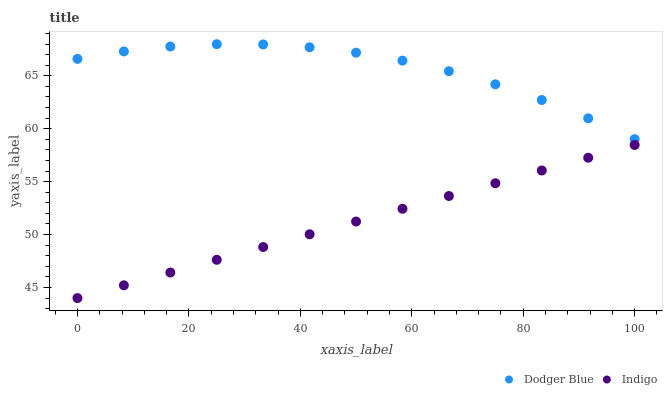Does Indigo have the minimum area under the curve?
Answer yes or no. Yes. Does Dodger Blue have the maximum area under the curve?
Answer yes or no. Yes. Does Dodger Blue have the minimum area under the curve?
Answer yes or no. No. Is Indigo the smoothest?
Answer yes or no. Yes. Is Dodger Blue the roughest?
Answer yes or no. Yes. Is Dodger Blue the smoothest?
Answer yes or no. No. Does Indigo have the lowest value?
Answer yes or no. Yes. Does Dodger Blue have the lowest value?
Answer yes or no. No. Does Dodger Blue have the highest value?
Answer yes or no. Yes. Is Indigo less than Dodger Blue?
Answer yes or no. Yes. Is Dodger Blue greater than Indigo?
Answer yes or no. Yes. Does Indigo intersect Dodger Blue?
Answer yes or no. No. 